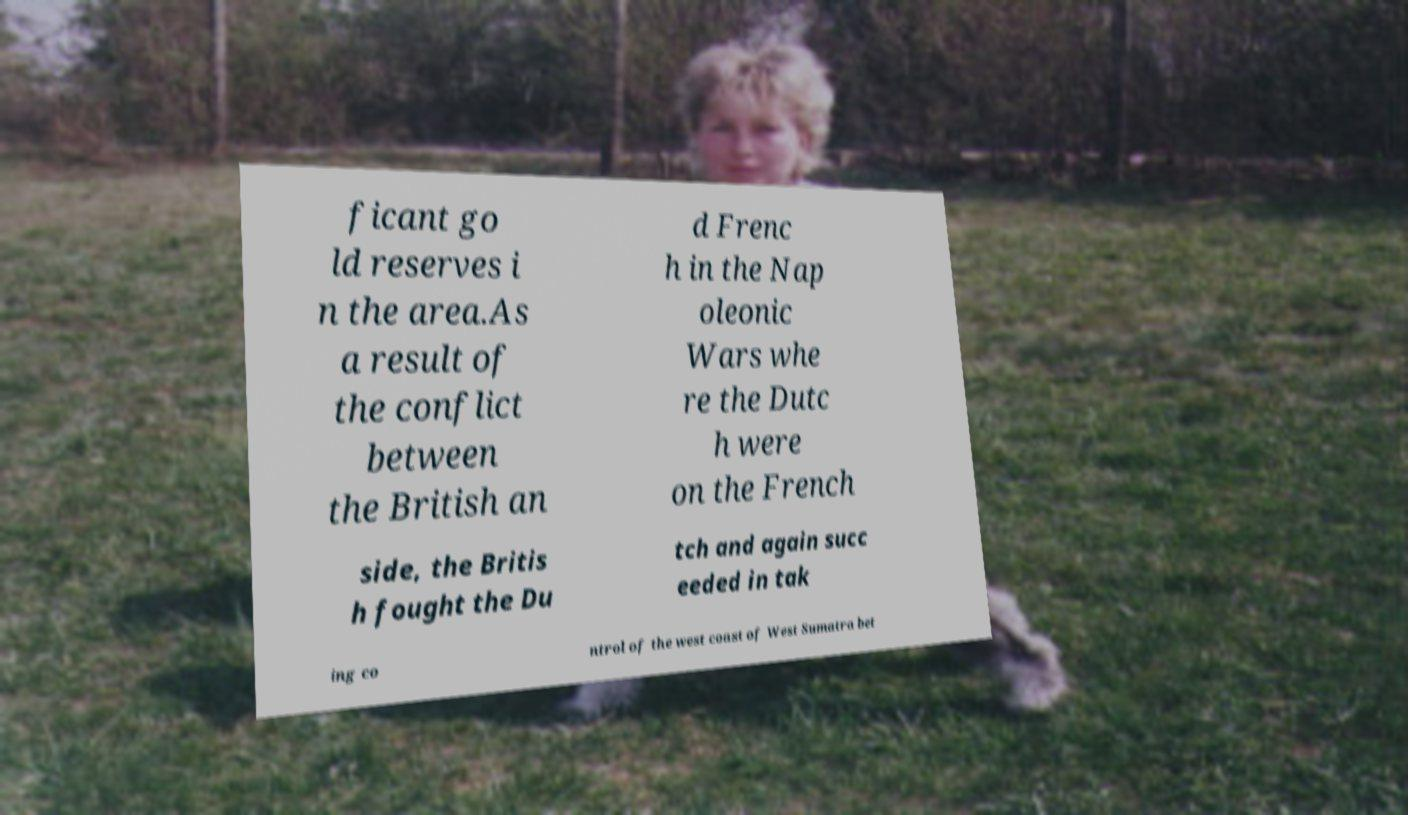For documentation purposes, I need the text within this image transcribed. Could you provide that? ficant go ld reserves i n the area.As a result of the conflict between the British an d Frenc h in the Nap oleonic Wars whe re the Dutc h were on the French side, the Britis h fought the Du tch and again succ eeded in tak ing co ntrol of the west coast of West Sumatra bet 